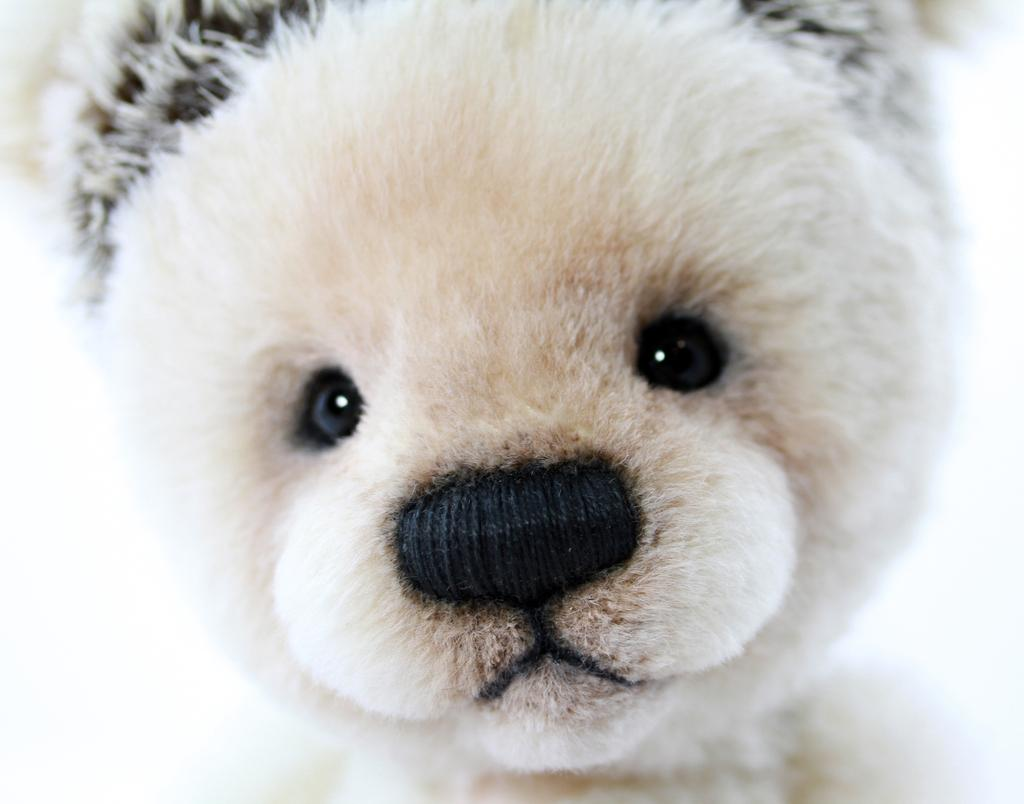What is the color of the teddy bear's head in the image? The teddy bear's head in the image is white. How many sticks are resting on the teddy bear's head in the image? There are no sticks present in the image, and therefore no sticks are resting on the teddy bear's head. 